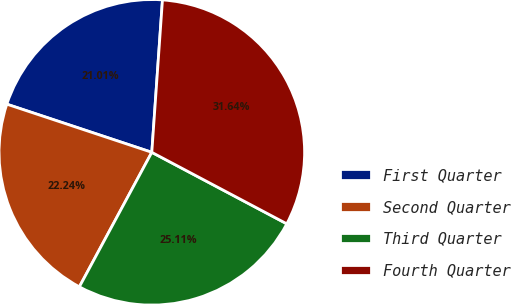Convert chart. <chart><loc_0><loc_0><loc_500><loc_500><pie_chart><fcel>First Quarter<fcel>Second Quarter<fcel>Third Quarter<fcel>Fourth Quarter<nl><fcel>21.01%<fcel>22.24%<fcel>25.11%<fcel>31.64%<nl></chart> 